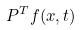Convert formula to latex. <formula><loc_0><loc_0><loc_500><loc_500>P ^ { T } f ( x , t )</formula> 